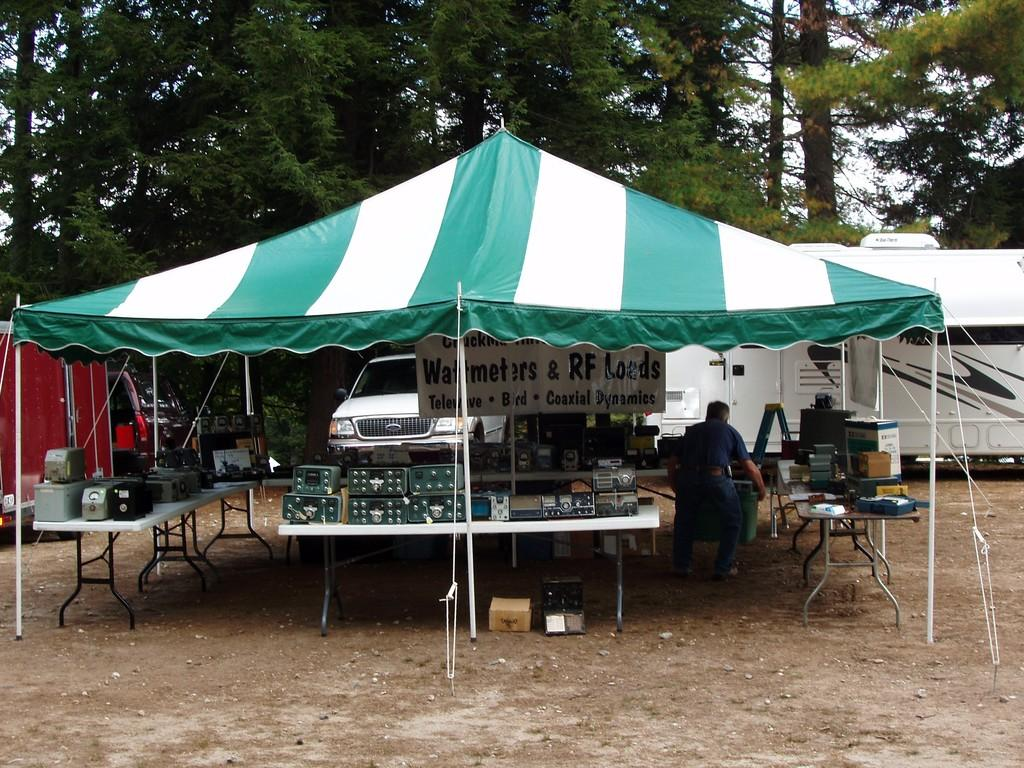What can be seen in the foreground of the image? There are electronics and a person under a tent in the foreground of the image. What is the setting of the image? The setting includes trees and a vehicle in the background, as well as the sky visible in the background. Can you describe the person under the tent? The person under the tent is not described in the provided facts, so we cannot provide any details about them. How many snails can be seen crawling on the electronics in the image? There are no snails visible in the image; it features electronics and a person under a tent in the foreground. What type of bird is perched on the vehicle in the background of the image? There is no bird present in the image; it features trees, a vehicle, and the sky visible in the background. 